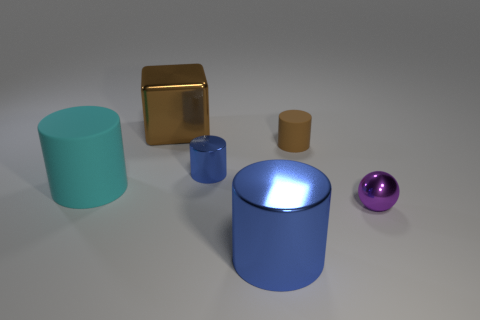Add 2 small metallic cylinders. How many objects exist? 8 Subtract all cylinders. How many objects are left? 2 Add 6 small cyan cylinders. How many small cyan cylinders exist? 6 Subtract 0 gray balls. How many objects are left? 6 Subtract all small green rubber things. Subtract all blue metal things. How many objects are left? 4 Add 1 brown cylinders. How many brown cylinders are left? 2 